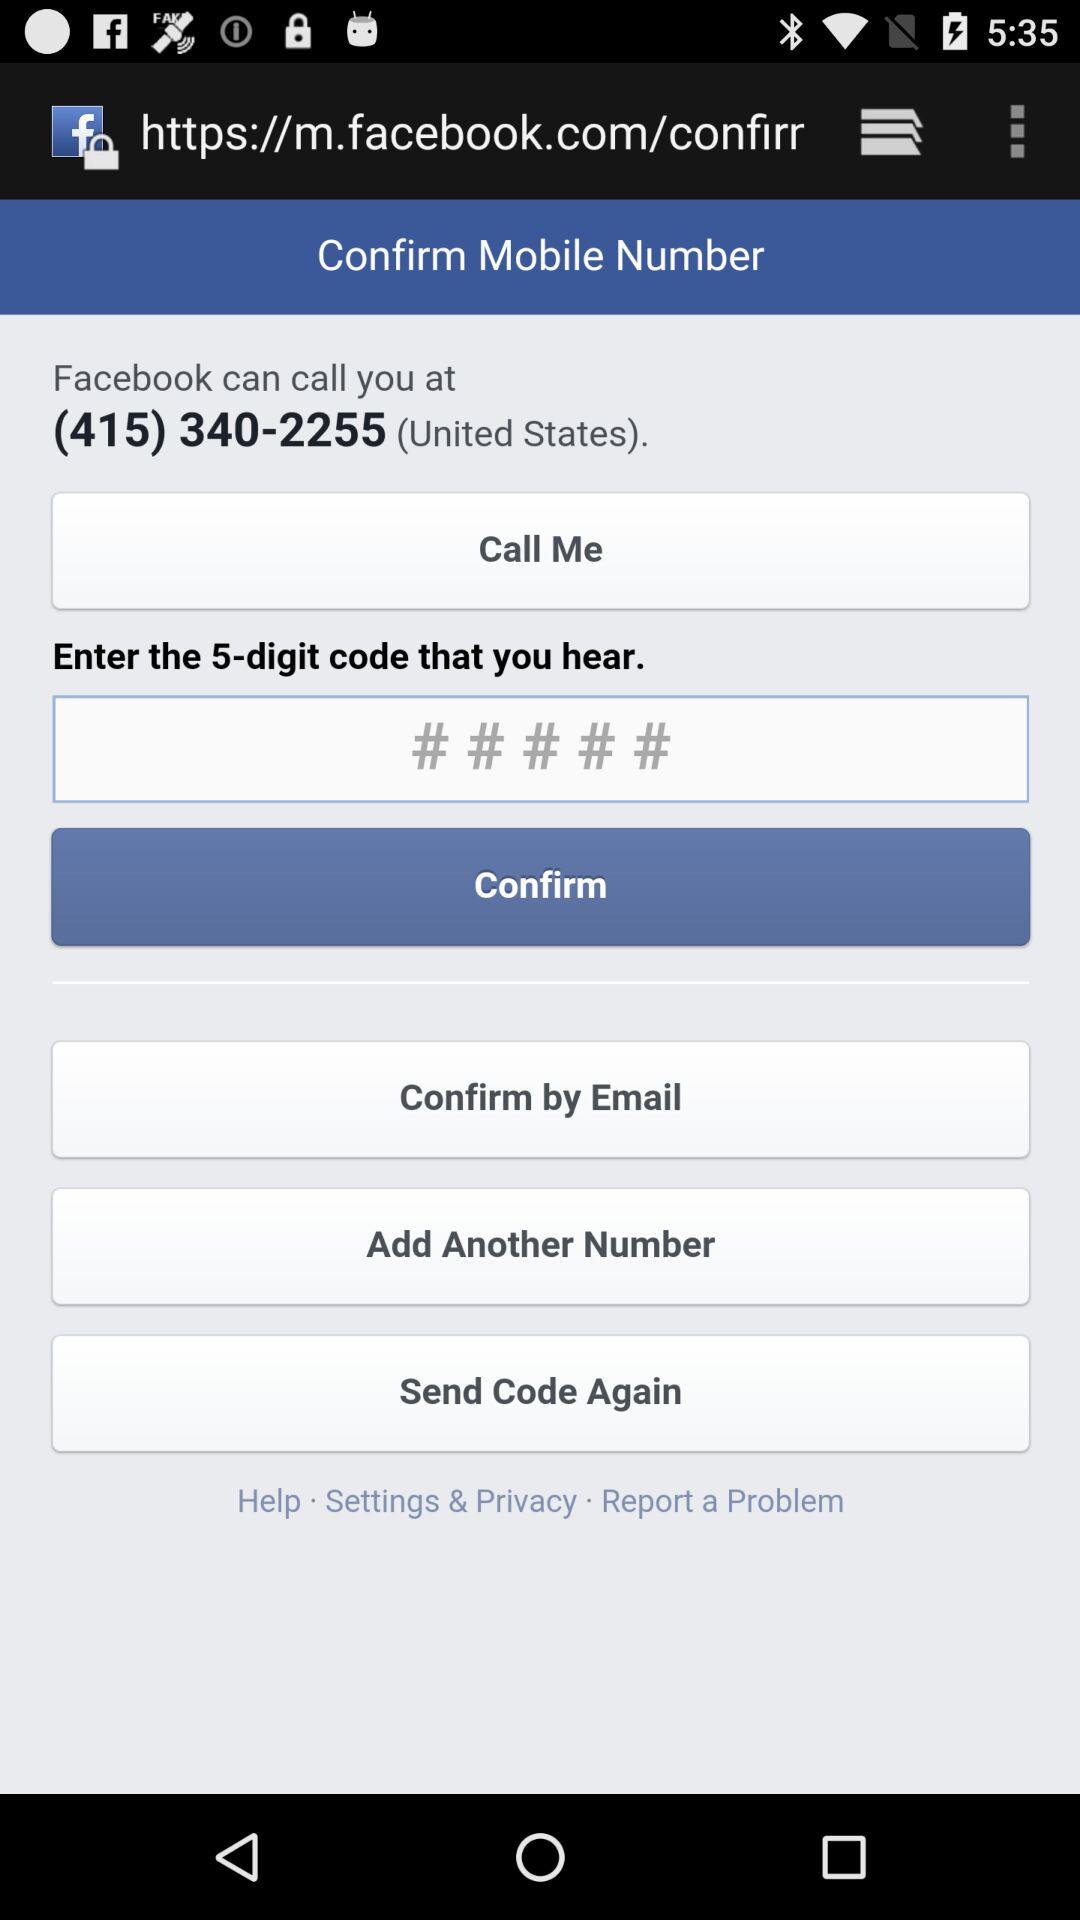How many different ways can I confirm my mobile number?
Answer the question using a single word or phrase. 3 